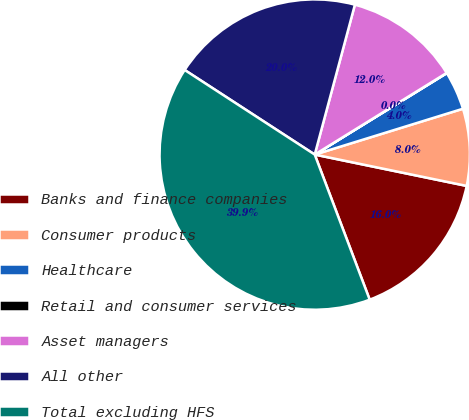<chart> <loc_0><loc_0><loc_500><loc_500><pie_chart><fcel>Banks and finance companies<fcel>Consumer products<fcel>Healthcare<fcel>Retail and consumer services<fcel>Asset managers<fcel>All other<fcel>Total excluding HFS<nl><fcel>16.0%<fcel>8.01%<fcel>4.02%<fcel>0.03%<fcel>12.01%<fcel>19.99%<fcel>39.94%<nl></chart> 